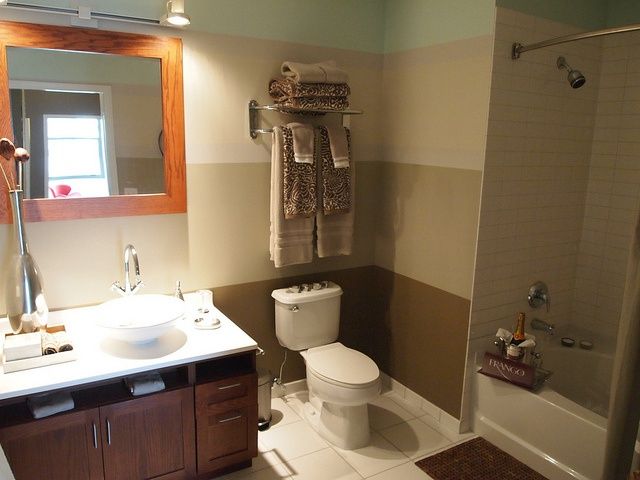Describe the objects in this image and their specific colors. I can see toilet in white, tan, and gray tones, sink in white, beige, and tan tones, sink in white, lightgray, and darkgray tones, and bottle in white, maroon, black, and gray tones in this image. 